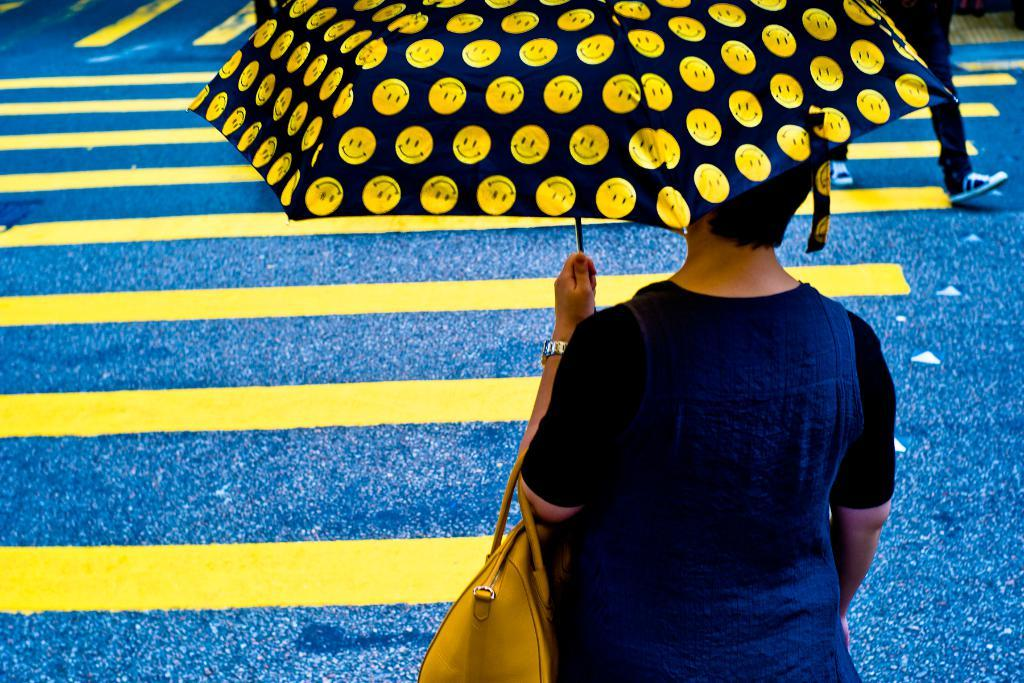What is the main subject of the image? There is a person in the image. What is the person holding in the image? The person is holding an umbrella and a handbag. Can you describe any other visible body parts of the person? Human legs are visible in the top right-hand side of the image. How many snails can be seen crawling on the person's handbag in the image? There are no snails visible in the image. What type of lizards are present in the image? There are no lizards present in the image. 